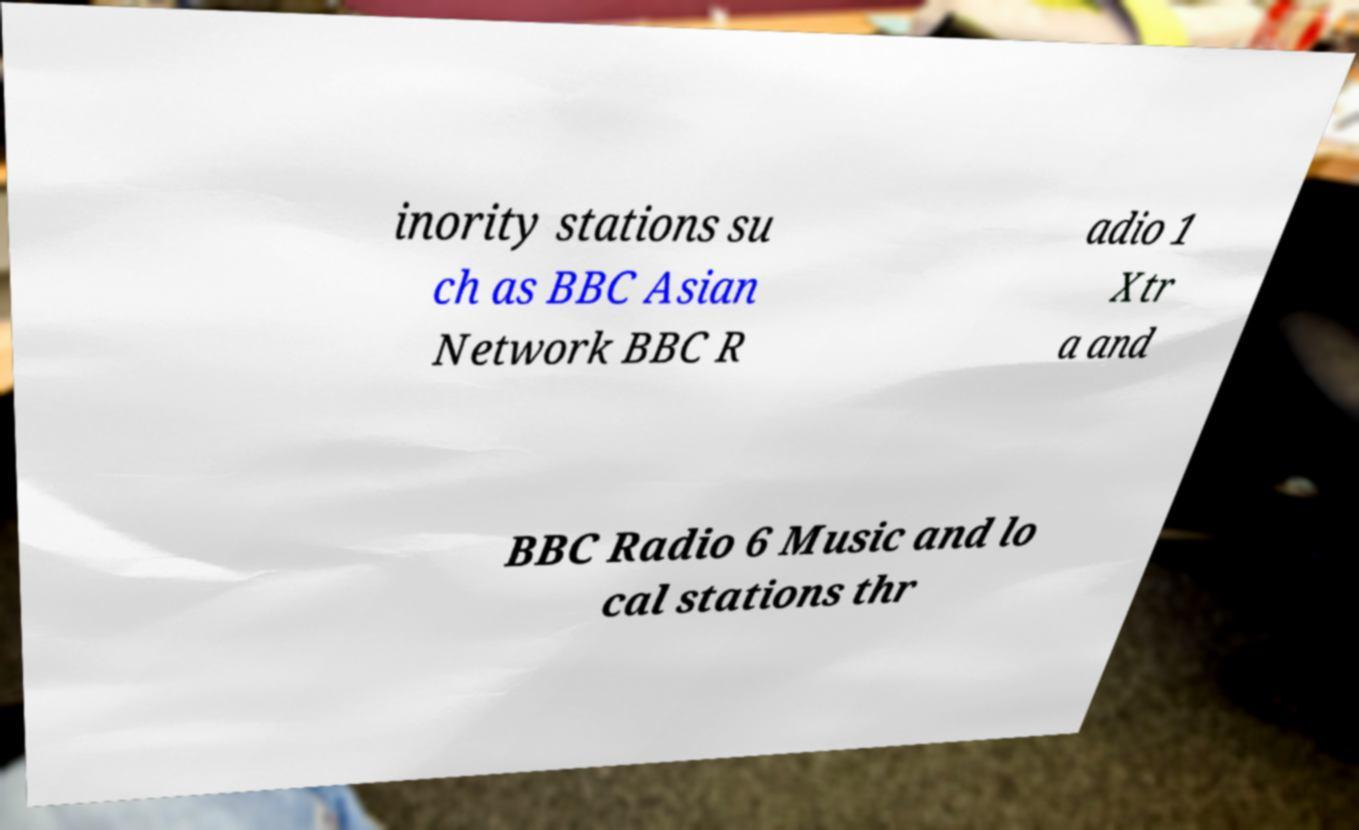I need the written content from this picture converted into text. Can you do that? inority stations su ch as BBC Asian Network BBC R adio 1 Xtr a and BBC Radio 6 Music and lo cal stations thr 